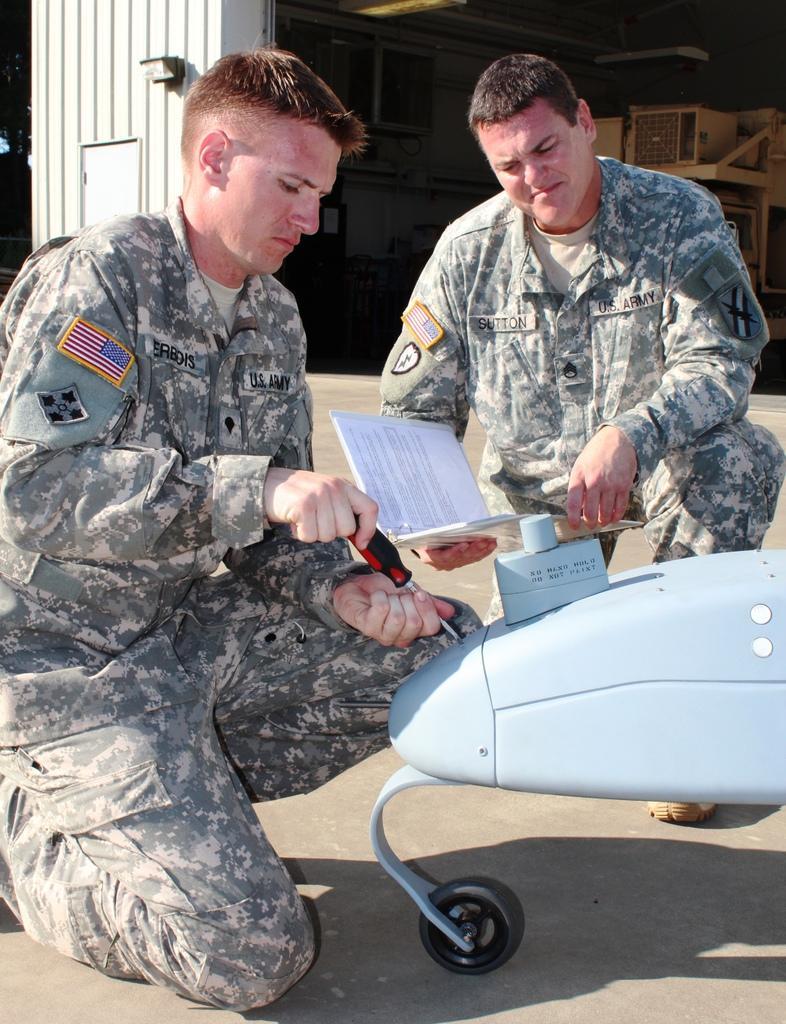Please provide a concise description of this image. In the center of the image there are two persons. There is an object at the right side of the image. In the background of the image there is a wall. 